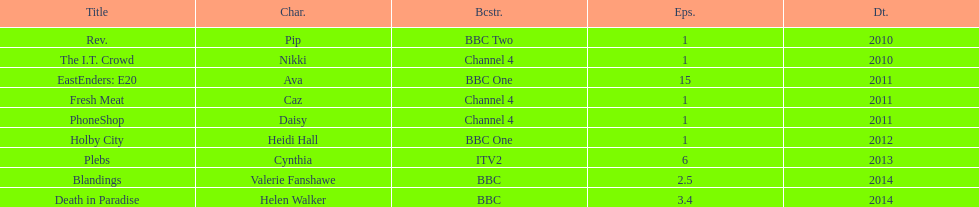How many television credits does this actress have? 9. 